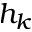Convert formula to latex. <formula><loc_0><loc_0><loc_500><loc_500>h _ { k }</formula> 